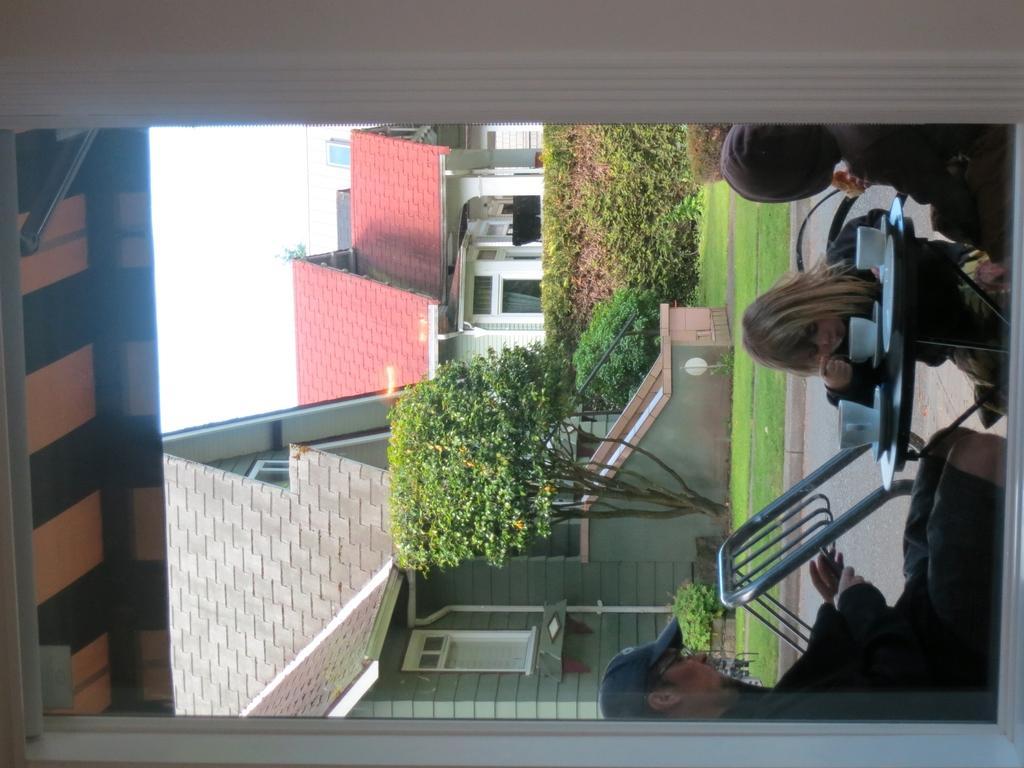How would you summarize this image in a sentence or two? The picture is an inverted image. In the right there is a table. On the table there are three cups and plates. There are chairs around the table. On the chairs people are sitting. In the background there are buildings, trees, sky. The picture is taken from a building. This is a window. 